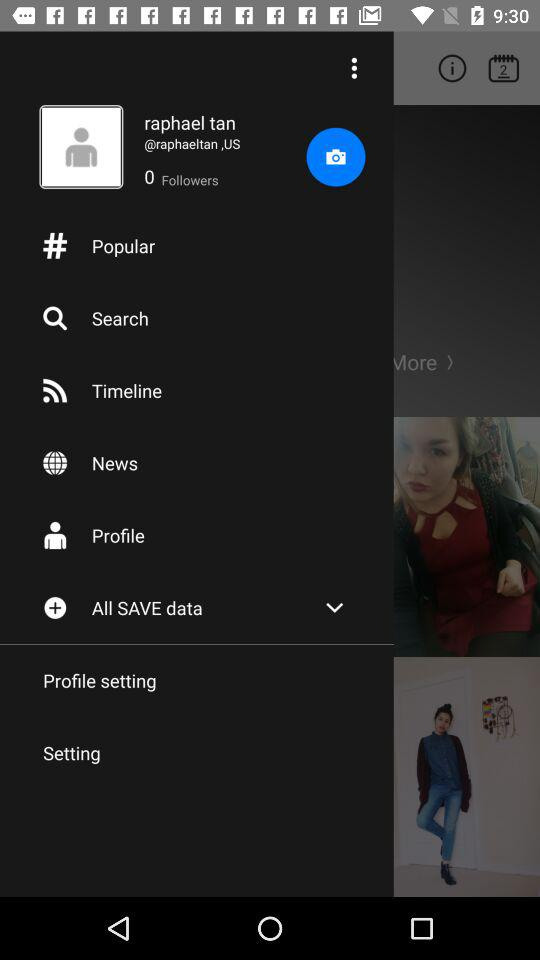What is the location? The location is the United States. 